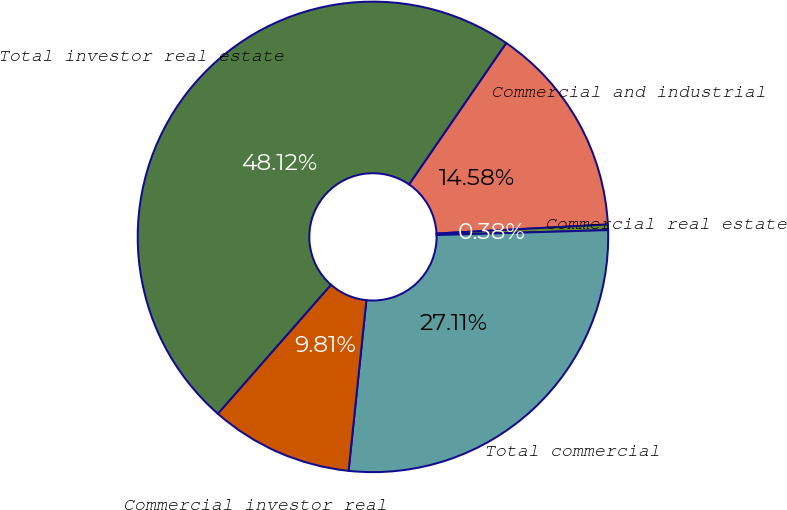Convert chart. <chart><loc_0><loc_0><loc_500><loc_500><pie_chart><fcel>Commercial and industrial<fcel>Commercial real estate<fcel>Total commercial<fcel>Commercial investor real<fcel>Total investor real estate<nl><fcel>14.58%<fcel>0.38%<fcel>27.11%<fcel>9.81%<fcel>48.12%<nl></chart> 